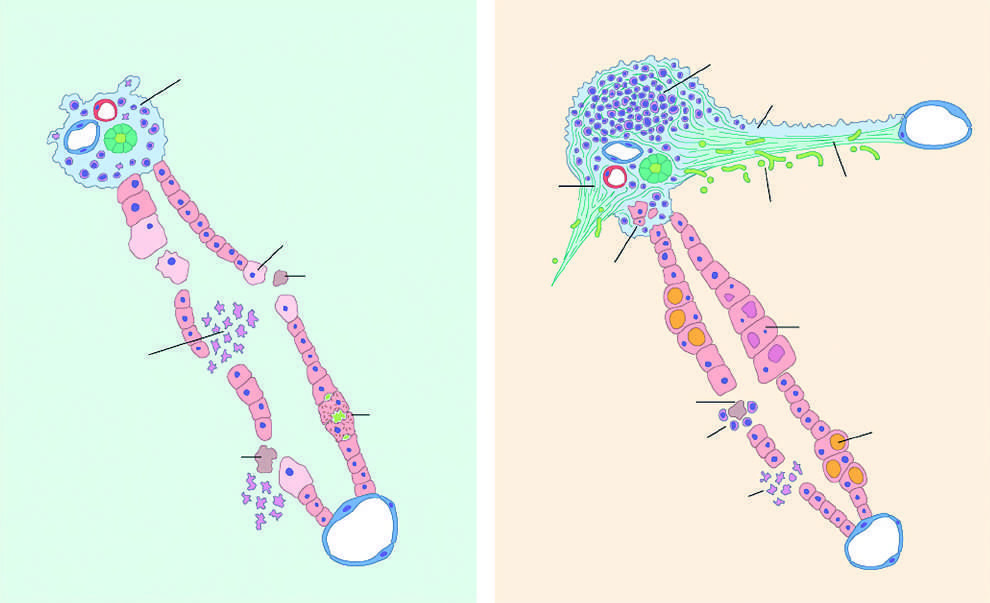re normal media for comparison dense and prominent?
Answer the question using a single word or phrase. No 